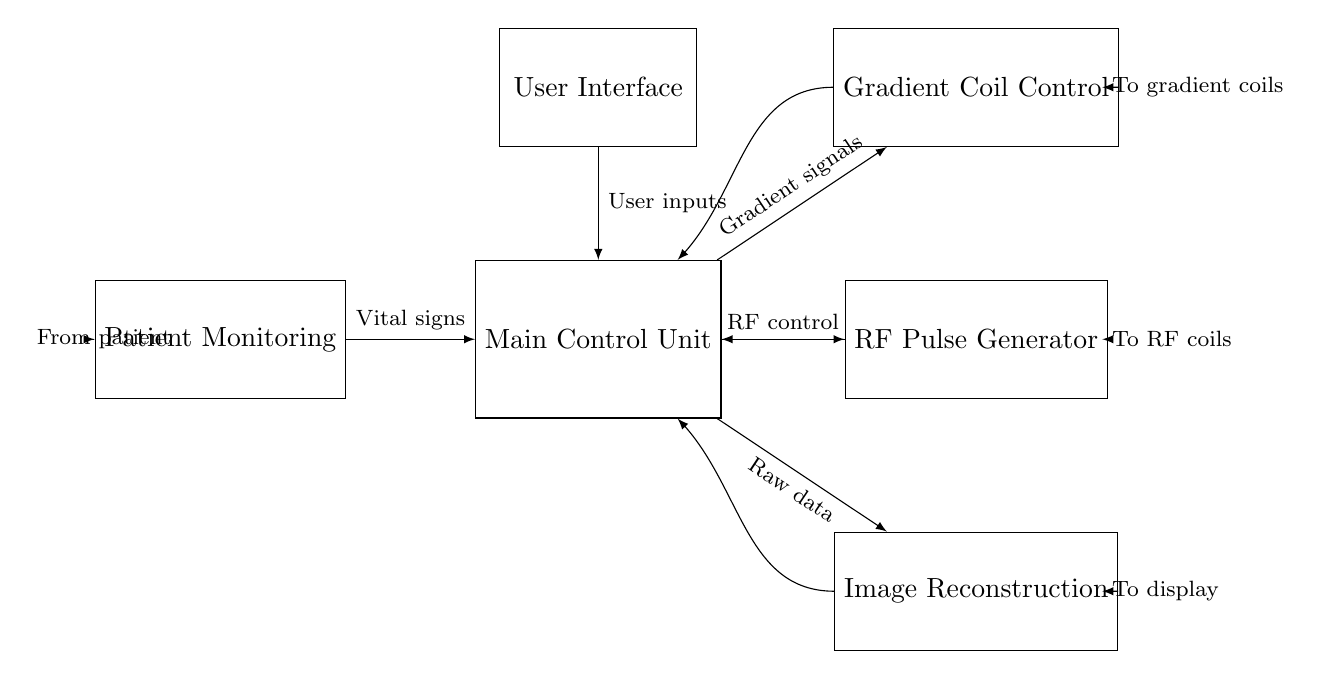What is the primary function of the Main Control Unit? The Main Control Unit orchestrates the overall operation of the MRI machine by managing signals to and from other components like the gradient coil control, RF pulse generator, and image reconstruction.
Answer: orchestrates operation What type of feedback does the Gradient Coil Control provide? The Gradient Coil Control provides feedback to the Main Control Unit, indicating the status of the gradient coils and ensuring they operate within specified limits to produce accurate imaging results.
Answer: feedback How many components are directly connected to the Main Control Unit? The Main Control Unit is connected to four components: the Gradient Coil Control, RF Pulse Generator, Image Reconstruction, and Patient Monitoring. This includes the User Interface indirectly through user inputs.
Answer: four What do the arrows in the diagram represent? The arrows indicate the direction of signal flow between components, showing how data, control signals, and feedback move through the system to achieve the MRI operation effectively.
Answer: signal flow Which component receives input from the Patient Monitoring? The Main Control Unit receives vital signs input from the Patient Monitoring component, allowing it to adjust operations based on patient condition during the MRI scan.
Answer: Main Control Unit What is the purpose of the RF Pulse Generator? The RF Pulse Generator produces radiofrequency pulses that are crucial for exciting the protons in the body being scanned, which helps in acquiring the MRI images.
Answer: exciting protons What type of system is depicted in the circuit diagram? The circuit diagram represents a digital control system for MRI machine operation, which involves various components coordinated for imaging and patient monitoring.
Answer: digital control system 